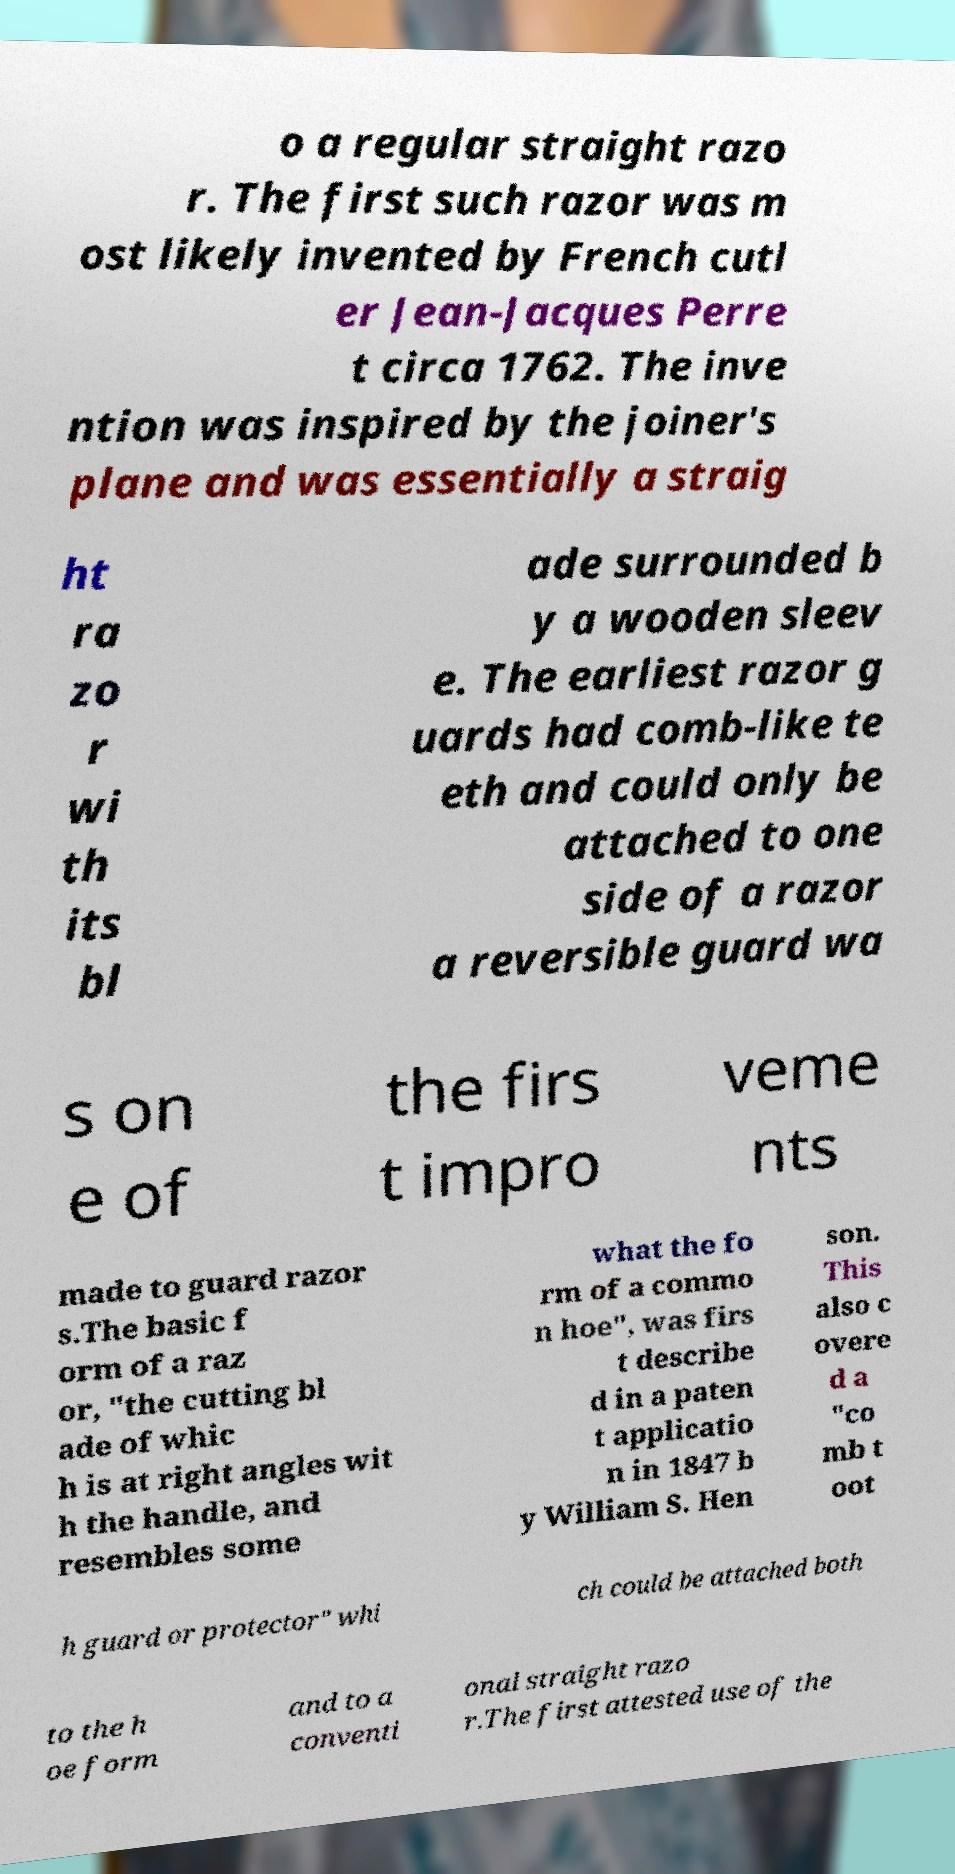For documentation purposes, I need the text within this image transcribed. Could you provide that? o a regular straight razo r. The first such razor was m ost likely invented by French cutl er Jean-Jacques Perre t circa 1762. The inve ntion was inspired by the joiner's plane and was essentially a straig ht ra zo r wi th its bl ade surrounded b y a wooden sleev e. The earliest razor g uards had comb-like te eth and could only be attached to one side of a razor a reversible guard wa s on e of the firs t impro veme nts made to guard razor s.The basic f orm of a raz or, "the cutting bl ade of whic h is at right angles wit h the handle, and resembles some what the fo rm of a commo n hoe", was firs t describe d in a paten t applicatio n in 1847 b y William S. Hen son. This also c overe d a "co mb t oot h guard or protector" whi ch could be attached both to the h oe form and to a conventi onal straight razo r.The first attested use of the 